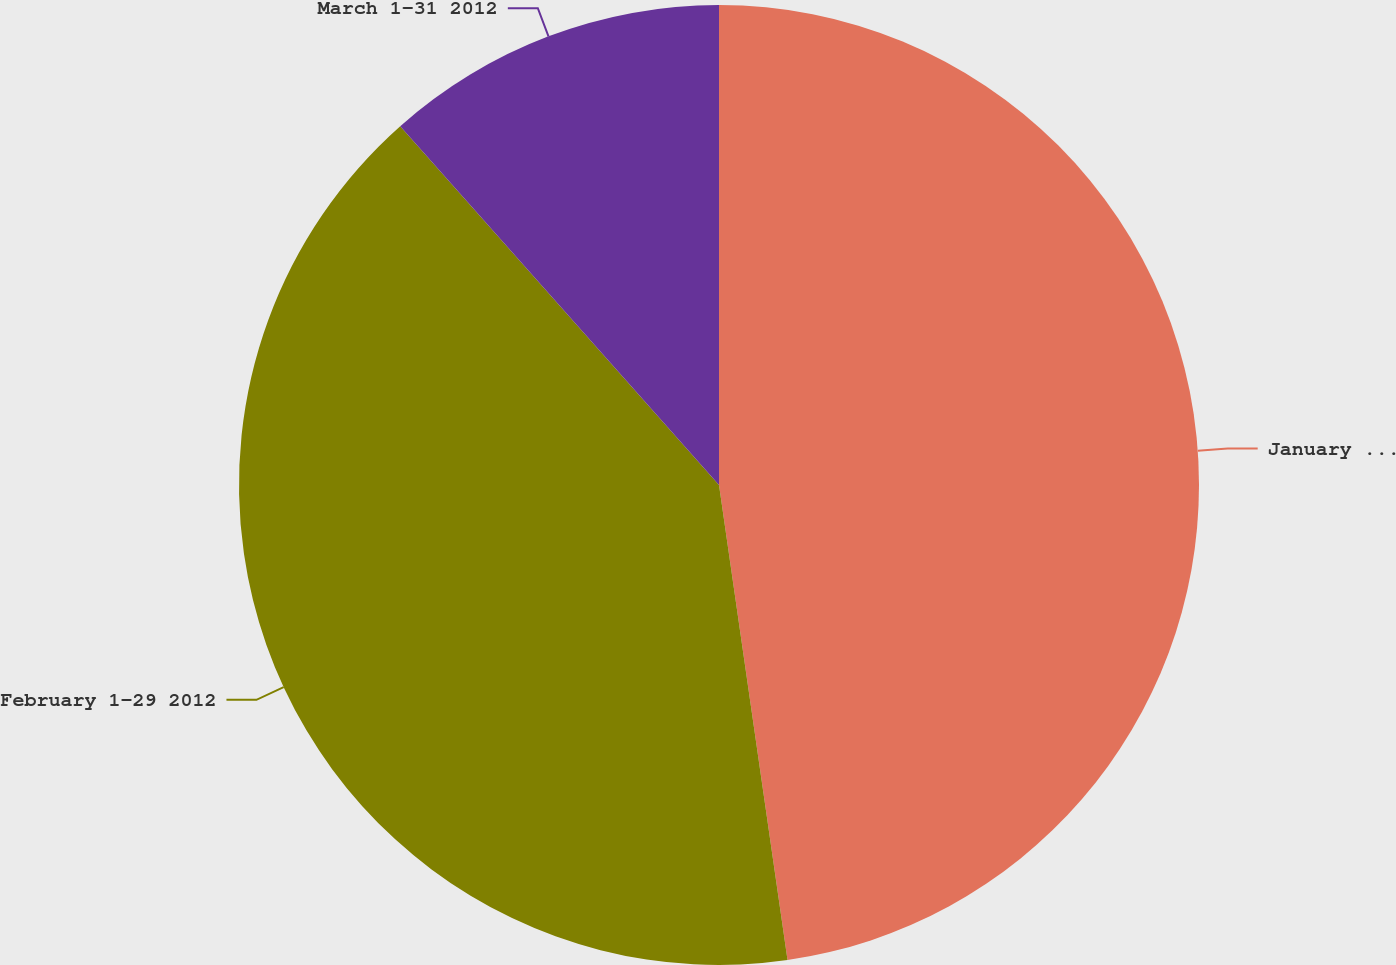Convert chart. <chart><loc_0><loc_0><loc_500><loc_500><pie_chart><fcel>January 1-31 2012<fcel>February 1-29 2012<fcel>March 1-31 2012<nl><fcel>47.72%<fcel>40.72%<fcel>11.56%<nl></chart> 